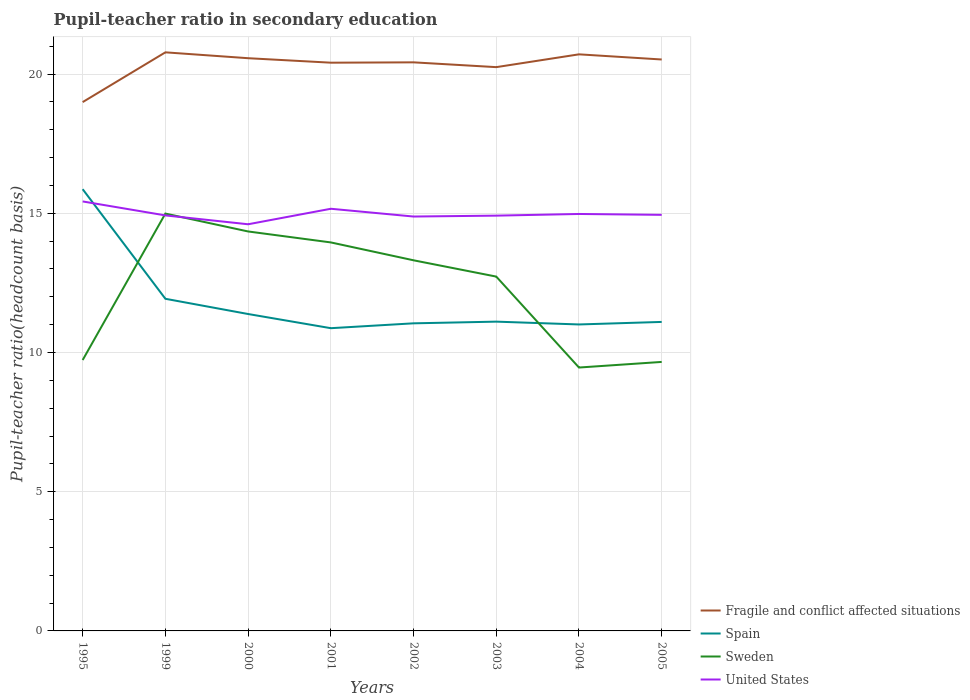Is the number of lines equal to the number of legend labels?
Offer a very short reply. Yes. Across all years, what is the maximum pupil-teacher ratio in secondary education in Spain?
Provide a succinct answer. 10.87. What is the total pupil-teacher ratio in secondary education in Fragile and conflict affected situations in the graph?
Your response must be concise. 0.17. What is the difference between the highest and the second highest pupil-teacher ratio in secondary education in Fragile and conflict affected situations?
Your response must be concise. 1.79. Is the pupil-teacher ratio in secondary education in United States strictly greater than the pupil-teacher ratio in secondary education in Sweden over the years?
Offer a terse response. No. Are the values on the major ticks of Y-axis written in scientific E-notation?
Make the answer very short. No. How many legend labels are there?
Your answer should be compact. 4. What is the title of the graph?
Keep it short and to the point. Pupil-teacher ratio in secondary education. Does "Colombia" appear as one of the legend labels in the graph?
Keep it short and to the point. No. What is the label or title of the X-axis?
Your answer should be compact. Years. What is the label or title of the Y-axis?
Your answer should be compact. Pupil-teacher ratio(headcount basis). What is the Pupil-teacher ratio(headcount basis) in Fragile and conflict affected situations in 1995?
Your answer should be very brief. 18.99. What is the Pupil-teacher ratio(headcount basis) in Spain in 1995?
Your answer should be compact. 15.87. What is the Pupil-teacher ratio(headcount basis) in Sweden in 1995?
Make the answer very short. 9.73. What is the Pupil-teacher ratio(headcount basis) of United States in 1995?
Make the answer very short. 15.43. What is the Pupil-teacher ratio(headcount basis) in Fragile and conflict affected situations in 1999?
Offer a very short reply. 20.78. What is the Pupil-teacher ratio(headcount basis) of Spain in 1999?
Your answer should be very brief. 11.93. What is the Pupil-teacher ratio(headcount basis) in Sweden in 1999?
Make the answer very short. 14.99. What is the Pupil-teacher ratio(headcount basis) of United States in 1999?
Offer a very short reply. 14.92. What is the Pupil-teacher ratio(headcount basis) of Fragile and conflict affected situations in 2000?
Make the answer very short. 20.57. What is the Pupil-teacher ratio(headcount basis) in Spain in 2000?
Your answer should be very brief. 11.38. What is the Pupil-teacher ratio(headcount basis) in Sweden in 2000?
Your answer should be very brief. 14.35. What is the Pupil-teacher ratio(headcount basis) of United States in 2000?
Make the answer very short. 14.61. What is the Pupil-teacher ratio(headcount basis) of Fragile and conflict affected situations in 2001?
Provide a short and direct response. 20.41. What is the Pupil-teacher ratio(headcount basis) in Spain in 2001?
Ensure brevity in your answer.  10.87. What is the Pupil-teacher ratio(headcount basis) of Sweden in 2001?
Offer a very short reply. 13.95. What is the Pupil-teacher ratio(headcount basis) in United States in 2001?
Your answer should be very brief. 15.16. What is the Pupil-teacher ratio(headcount basis) in Fragile and conflict affected situations in 2002?
Offer a terse response. 20.42. What is the Pupil-teacher ratio(headcount basis) in Spain in 2002?
Provide a succinct answer. 11.05. What is the Pupil-teacher ratio(headcount basis) of Sweden in 2002?
Your answer should be compact. 13.31. What is the Pupil-teacher ratio(headcount basis) in United States in 2002?
Keep it short and to the point. 14.88. What is the Pupil-teacher ratio(headcount basis) of Fragile and conflict affected situations in 2003?
Offer a terse response. 20.25. What is the Pupil-teacher ratio(headcount basis) in Spain in 2003?
Provide a short and direct response. 11.11. What is the Pupil-teacher ratio(headcount basis) in Sweden in 2003?
Make the answer very short. 12.73. What is the Pupil-teacher ratio(headcount basis) in United States in 2003?
Offer a very short reply. 14.92. What is the Pupil-teacher ratio(headcount basis) in Fragile and conflict affected situations in 2004?
Make the answer very short. 20.71. What is the Pupil-teacher ratio(headcount basis) in Spain in 2004?
Your answer should be compact. 11.01. What is the Pupil-teacher ratio(headcount basis) in Sweden in 2004?
Your answer should be very brief. 9.46. What is the Pupil-teacher ratio(headcount basis) in United States in 2004?
Ensure brevity in your answer.  14.98. What is the Pupil-teacher ratio(headcount basis) of Fragile and conflict affected situations in 2005?
Provide a succinct answer. 20.52. What is the Pupil-teacher ratio(headcount basis) in Spain in 2005?
Ensure brevity in your answer.  11.1. What is the Pupil-teacher ratio(headcount basis) in Sweden in 2005?
Make the answer very short. 9.66. What is the Pupil-teacher ratio(headcount basis) in United States in 2005?
Provide a succinct answer. 14.94. Across all years, what is the maximum Pupil-teacher ratio(headcount basis) in Fragile and conflict affected situations?
Provide a short and direct response. 20.78. Across all years, what is the maximum Pupil-teacher ratio(headcount basis) of Spain?
Offer a very short reply. 15.87. Across all years, what is the maximum Pupil-teacher ratio(headcount basis) of Sweden?
Provide a short and direct response. 14.99. Across all years, what is the maximum Pupil-teacher ratio(headcount basis) of United States?
Offer a very short reply. 15.43. Across all years, what is the minimum Pupil-teacher ratio(headcount basis) of Fragile and conflict affected situations?
Your response must be concise. 18.99. Across all years, what is the minimum Pupil-teacher ratio(headcount basis) of Spain?
Your answer should be very brief. 10.87. Across all years, what is the minimum Pupil-teacher ratio(headcount basis) in Sweden?
Your answer should be very brief. 9.46. Across all years, what is the minimum Pupil-teacher ratio(headcount basis) of United States?
Keep it short and to the point. 14.61. What is the total Pupil-teacher ratio(headcount basis) of Fragile and conflict affected situations in the graph?
Offer a very short reply. 162.66. What is the total Pupil-teacher ratio(headcount basis) in Spain in the graph?
Offer a very short reply. 94.31. What is the total Pupil-teacher ratio(headcount basis) in Sweden in the graph?
Provide a succinct answer. 98.18. What is the total Pupil-teacher ratio(headcount basis) of United States in the graph?
Provide a succinct answer. 119.84. What is the difference between the Pupil-teacher ratio(headcount basis) of Fragile and conflict affected situations in 1995 and that in 1999?
Your answer should be very brief. -1.79. What is the difference between the Pupil-teacher ratio(headcount basis) in Spain in 1995 and that in 1999?
Make the answer very short. 3.94. What is the difference between the Pupil-teacher ratio(headcount basis) of Sweden in 1995 and that in 1999?
Give a very brief answer. -5.26. What is the difference between the Pupil-teacher ratio(headcount basis) in United States in 1995 and that in 1999?
Make the answer very short. 0.5. What is the difference between the Pupil-teacher ratio(headcount basis) of Fragile and conflict affected situations in 1995 and that in 2000?
Ensure brevity in your answer.  -1.58. What is the difference between the Pupil-teacher ratio(headcount basis) of Spain in 1995 and that in 2000?
Provide a succinct answer. 4.48. What is the difference between the Pupil-teacher ratio(headcount basis) in Sweden in 1995 and that in 2000?
Your answer should be compact. -4.62. What is the difference between the Pupil-teacher ratio(headcount basis) in United States in 1995 and that in 2000?
Give a very brief answer. 0.82. What is the difference between the Pupil-teacher ratio(headcount basis) of Fragile and conflict affected situations in 1995 and that in 2001?
Your answer should be compact. -1.42. What is the difference between the Pupil-teacher ratio(headcount basis) of Spain in 1995 and that in 2001?
Your answer should be very brief. 4.99. What is the difference between the Pupil-teacher ratio(headcount basis) of Sweden in 1995 and that in 2001?
Provide a short and direct response. -4.22. What is the difference between the Pupil-teacher ratio(headcount basis) of United States in 1995 and that in 2001?
Your answer should be compact. 0.26. What is the difference between the Pupil-teacher ratio(headcount basis) in Fragile and conflict affected situations in 1995 and that in 2002?
Your answer should be compact. -1.43. What is the difference between the Pupil-teacher ratio(headcount basis) in Spain in 1995 and that in 2002?
Give a very brief answer. 4.82. What is the difference between the Pupil-teacher ratio(headcount basis) of Sweden in 1995 and that in 2002?
Your answer should be very brief. -3.58. What is the difference between the Pupil-teacher ratio(headcount basis) of United States in 1995 and that in 2002?
Offer a terse response. 0.54. What is the difference between the Pupil-teacher ratio(headcount basis) of Fragile and conflict affected situations in 1995 and that in 2003?
Offer a terse response. -1.26. What is the difference between the Pupil-teacher ratio(headcount basis) of Spain in 1995 and that in 2003?
Ensure brevity in your answer.  4.76. What is the difference between the Pupil-teacher ratio(headcount basis) of Sweden in 1995 and that in 2003?
Your answer should be compact. -3. What is the difference between the Pupil-teacher ratio(headcount basis) in United States in 1995 and that in 2003?
Ensure brevity in your answer.  0.51. What is the difference between the Pupil-teacher ratio(headcount basis) in Fragile and conflict affected situations in 1995 and that in 2004?
Provide a short and direct response. -1.72. What is the difference between the Pupil-teacher ratio(headcount basis) in Spain in 1995 and that in 2004?
Offer a very short reply. 4.86. What is the difference between the Pupil-teacher ratio(headcount basis) of Sweden in 1995 and that in 2004?
Offer a very short reply. 0.27. What is the difference between the Pupil-teacher ratio(headcount basis) in United States in 1995 and that in 2004?
Ensure brevity in your answer.  0.45. What is the difference between the Pupil-teacher ratio(headcount basis) of Fragile and conflict affected situations in 1995 and that in 2005?
Offer a terse response. -1.53. What is the difference between the Pupil-teacher ratio(headcount basis) in Spain in 1995 and that in 2005?
Offer a very short reply. 4.77. What is the difference between the Pupil-teacher ratio(headcount basis) of Sweden in 1995 and that in 2005?
Provide a short and direct response. 0.07. What is the difference between the Pupil-teacher ratio(headcount basis) in United States in 1995 and that in 2005?
Offer a very short reply. 0.48. What is the difference between the Pupil-teacher ratio(headcount basis) of Fragile and conflict affected situations in 1999 and that in 2000?
Ensure brevity in your answer.  0.21. What is the difference between the Pupil-teacher ratio(headcount basis) in Spain in 1999 and that in 2000?
Provide a short and direct response. 0.55. What is the difference between the Pupil-teacher ratio(headcount basis) of Sweden in 1999 and that in 2000?
Give a very brief answer. 0.64. What is the difference between the Pupil-teacher ratio(headcount basis) of United States in 1999 and that in 2000?
Your answer should be compact. 0.32. What is the difference between the Pupil-teacher ratio(headcount basis) of Fragile and conflict affected situations in 1999 and that in 2001?
Provide a short and direct response. 0.37. What is the difference between the Pupil-teacher ratio(headcount basis) of Spain in 1999 and that in 2001?
Ensure brevity in your answer.  1.06. What is the difference between the Pupil-teacher ratio(headcount basis) in Sweden in 1999 and that in 2001?
Keep it short and to the point. 1.04. What is the difference between the Pupil-teacher ratio(headcount basis) in United States in 1999 and that in 2001?
Ensure brevity in your answer.  -0.24. What is the difference between the Pupil-teacher ratio(headcount basis) of Fragile and conflict affected situations in 1999 and that in 2002?
Your answer should be very brief. 0.36. What is the difference between the Pupil-teacher ratio(headcount basis) of Spain in 1999 and that in 2002?
Offer a very short reply. 0.88. What is the difference between the Pupil-teacher ratio(headcount basis) of Sweden in 1999 and that in 2002?
Provide a short and direct response. 1.68. What is the difference between the Pupil-teacher ratio(headcount basis) of United States in 1999 and that in 2002?
Your response must be concise. 0.04. What is the difference between the Pupil-teacher ratio(headcount basis) in Fragile and conflict affected situations in 1999 and that in 2003?
Your answer should be compact. 0.53. What is the difference between the Pupil-teacher ratio(headcount basis) of Spain in 1999 and that in 2003?
Ensure brevity in your answer.  0.82. What is the difference between the Pupil-teacher ratio(headcount basis) in Sweden in 1999 and that in 2003?
Offer a very short reply. 2.26. What is the difference between the Pupil-teacher ratio(headcount basis) of United States in 1999 and that in 2003?
Your answer should be compact. 0.01. What is the difference between the Pupil-teacher ratio(headcount basis) of Fragile and conflict affected situations in 1999 and that in 2004?
Offer a very short reply. 0.07. What is the difference between the Pupil-teacher ratio(headcount basis) of Spain in 1999 and that in 2004?
Your response must be concise. 0.92. What is the difference between the Pupil-teacher ratio(headcount basis) in Sweden in 1999 and that in 2004?
Give a very brief answer. 5.53. What is the difference between the Pupil-teacher ratio(headcount basis) in United States in 1999 and that in 2004?
Make the answer very short. -0.05. What is the difference between the Pupil-teacher ratio(headcount basis) in Fragile and conflict affected situations in 1999 and that in 2005?
Ensure brevity in your answer.  0.26. What is the difference between the Pupil-teacher ratio(headcount basis) of Spain in 1999 and that in 2005?
Your response must be concise. 0.83. What is the difference between the Pupil-teacher ratio(headcount basis) in Sweden in 1999 and that in 2005?
Give a very brief answer. 5.33. What is the difference between the Pupil-teacher ratio(headcount basis) of United States in 1999 and that in 2005?
Make the answer very short. -0.02. What is the difference between the Pupil-teacher ratio(headcount basis) of Fragile and conflict affected situations in 2000 and that in 2001?
Your response must be concise. 0.16. What is the difference between the Pupil-teacher ratio(headcount basis) in Spain in 2000 and that in 2001?
Give a very brief answer. 0.51. What is the difference between the Pupil-teacher ratio(headcount basis) in Sweden in 2000 and that in 2001?
Offer a very short reply. 0.39. What is the difference between the Pupil-teacher ratio(headcount basis) in United States in 2000 and that in 2001?
Your answer should be compact. -0.56. What is the difference between the Pupil-teacher ratio(headcount basis) in Fragile and conflict affected situations in 2000 and that in 2002?
Provide a short and direct response. 0.15. What is the difference between the Pupil-teacher ratio(headcount basis) in Spain in 2000 and that in 2002?
Your answer should be very brief. 0.33. What is the difference between the Pupil-teacher ratio(headcount basis) of Sweden in 2000 and that in 2002?
Offer a very short reply. 1.04. What is the difference between the Pupil-teacher ratio(headcount basis) in United States in 2000 and that in 2002?
Ensure brevity in your answer.  -0.28. What is the difference between the Pupil-teacher ratio(headcount basis) of Fragile and conflict affected situations in 2000 and that in 2003?
Offer a terse response. 0.32. What is the difference between the Pupil-teacher ratio(headcount basis) of Spain in 2000 and that in 2003?
Ensure brevity in your answer.  0.27. What is the difference between the Pupil-teacher ratio(headcount basis) in Sweden in 2000 and that in 2003?
Give a very brief answer. 1.62. What is the difference between the Pupil-teacher ratio(headcount basis) of United States in 2000 and that in 2003?
Give a very brief answer. -0.31. What is the difference between the Pupil-teacher ratio(headcount basis) of Fragile and conflict affected situations in 2000 and that in 2004?
Offer a very short reply. -0.14. What is the difference between the Pupil-teacher ratio(headcount basis) in Sweden in 2000 and that in 2004?
Keep it short and to the point. 4.89. What is the difference between the Pupil-teacher ratio(headcount basis) in United States in 2000 and that in 2004?
Your answer should be very brief. -0.37. What is the difference between the Pupil-teacher ratio(headcount basis) of Fragile and conflict affected situations in 2000 and that in 2005?
Your response must be concise. 0.05. What is the difference between the Pupil-teacher ratio(headcount basis) of Spain in 2000 and that in 2005?
Provide a short and direct response. 0.28. What is the difference between the Pupil-teacher ratio(headcount basis) in Sweden in 2000 and that in 2005?
Your answer should be very brief. 4.69. What is the difference between the Pupil-teacher ratio(headcount basis) of United States in 2000 and that in 2005?
Keep it short and to the point. -0.34. What is the difference between the Pupil-teacher ratio(headcount basis) of Fragile and conflict affected situations in 2001 and that in 2002?
Provide a short and direct response. -0.01. What is the difference between the Pupil-teacher ratio(headcount basis) in Spain in 2001 and that in 2002?
Ensure brevity in your answer.  -0.17. What is the difference between the Pupil-teacher ratio(headcount basis) of Sweden in 2001 and that in 2002?
Your answer should be compact. 0.64. What is the difference between the Pupil-teacher ratio(headcount basis) in United States in 2001 and that in 2002?
Your answer should be compact. 0.28. What is the difference between the Pupil-teacher ratio(headcount basis) of Fragile and conflict affected situations in 2001 and that in 2003?
Offer a terse response. 0.16. What is the difference between the Pupil-teacher ratio(headcount basis) in Spain in 2001 and that in 2003?
Keep it short and to the point. -0.24. What is the difference between the Pupil-teacher ratio(headcount basis) of Sweden in 2001 and that in 2003?
Provide a succinct answer. 1.23. What is the difference between the Pupil-teacher ratio(headcount basis) in United States in 2001 and that in 2003?
Make the answer very short. 0.25. What is the difference between the Pupil-teacher ratio(headcount basis) in Fragile and conflict affected situations in 2001 and that in 2004?
Keep it short and to the point. -0.3. What is the difference between the Pupil-teacher ratio(headcount basis) in Spain in 2001 and that in 2004?
Your response must be concise. -0.13. What is the difference between the Pupil-teacher ratio(headcount basis) of Sweden in 2001 and that in 2004?
Offer a very short reply. 4.49. What is the difference between the Pupil-teacher ratio(headcount basis) in United States in 2001 and that in 2004?
Provide a succinct answer. 0.19. What is the difference between the Pupil-teacher ratio(headcount basis) in Fragile and conflict affected situations in 2001 and that in 2005?
Give a very brief answer. -0.11. What is the difference between the Pupil-teacher ratio(headcount basis) in Spain in 2001 and that in 2005?
Give a very brief answer. -0.22. What is the difference between the Pupil-teacher ratio(headcount basis) of Sweden in 2001 and that in 2005?
Provide a succinct answer. 4.29. What is the difference between the Pupil-teacher ratio(headcount basis) of United States in 2001 and that in 2005?
Offer a terse response. 0.22. What is the difference between the Pupil-teacher ratio(headcount basis) of Fragile and conflict affected situations in 2002 and that in 2003?
Make the answer very short. 0.17. What is the difference between the Pupil-teacher ratio(headcount basis) of Spain in 2002 and that in 2003?
Keep it short and to the point. -0.06. What is the difference between the Pupil-teacher ratio(headcount basis) in Sweden in 2002 and that in 2003?
Your answer should be compact. 0.59. What is the difference between the Pupil-teacher ratio(headcount basis) of United States in 2002 and that in 2003?
Provide a short and direct response. -0.03. What is the difference between the Pupil-teacher ratio(headcount basis) of Fragile and conflict affected situations in 2002 and that in 2004?
Your answer should be very brief. -0.29. What is the difference between the Pupil-teacher ratio(headcount basis) in Spain in 2002 and that in 2004?
Keep it short and to the point. 0.04. What is the difference between the Pupil-teacher ratio(headcount basis) in Sweden in 2002 and that in 2004?
Give a very brief answer. 3.85. What is the difference between the Pupil-teacher ratio(headcount basis) in United States in 2002 and that in 2004?
Make the answer very short. -0.09. What is the difference between the Pupil-teacher ratio(headcount basis) of Fragile and conflict affected situations in 2002 and that in 2005?
Your answer should be very brief. -0.1. What is the difference between the Pupil-teacher ratio(headcount basis) of Spain in 2002 and that in 2005?
Your answer should be very brief. -0.05. What is the difference between the Pupil-teacher ratio(headcount basis) in Sweden in 2002 and that in 2005?
Your answer should be compact. 3.65. What is the difference between the Pupil-teacher ratio(headcount basis) in United States in 2002 and that in 2005?
Provide a short and direct response. -0.06. What is the difference between the Pupil-teacher ratio(headcount basis) in Fragile and conflict affected situations in 2003 and that in 2004?
Give a very brief answer. -0.46. What is the difference between the Pupil-teacher ratio(headcount basis) in Spain in 2003 and that in 2004?
Offer a very short reply. 0.1. What is the difference between the Pupil-teacher ratio(headcount basis) of Sweden in 2003 and that in 2004?
Offer a very short reply. 3.27. What is the difference between the Pupil-teacher ratio(headcount basis) of United States in 2003 and that in 2004?
Make the answer very short. -0.06. What is the difference between the Pupil-teacher ratio(headcount basis) in Fragile and conflict affected situations in 2003 and that in 2005?
Offer a terse response. -0.27. What is the difference between the Pupil-teacher ratio(headcount basis) in Spain in 2003 and that in 2005?
Provide a short and direct response. 0.01. What is the difference between the Pupil-teacher ratio(headcount basis) of Sweden in 2003 and that in 2005?
Give a very brief answer. 3.06. What is the difference between the Pupil-teacher ratio(headcount basis) of United States in 2003 and that in 2005?
Make the answer very short. -0.03. What is the difference between the Pupil-teacher ratio(headcount basis) in Fragile and conflict affected situations in 2004 and that in 2005?
Provide a short and direct response. 0.19. What is the difference between the Pupil-teacher ratio(headcount basis) in Spain in 2004 and that in 2005?
Keep it short and to the point. -0.09. What is the difference between the Pupil-teacher ratio(headcount basis) of Sweden in 2004 and that in 2005?
Make the answer very short. -0.2. What is the difference between the Pupil-teacher ratio(headcount basis) in United States in 2004 and that in 2005?
Ensure brevity in your answer.  0.03. What is the difference between the Pupil-teacher ratio(headcount basis) of Fragile and conflict affected situations in 1995 and the Pupil-teacher ratio(headcount basis) of Spain in 1999?
Your answer should be compact. 7.06. What is the difference between the Pupil-teacher ratio(headcount basis) in Fragile and conflict affected situations in 1995 and the Pupil-teacher ratio(headcount basis) in Sweden in 1999?
Offer a very short reply. 4. What is the difference between the Pupil-teacher ratio(headcount basis) in Fragile and conflict affected situations in 1995 and the Pupil-teacher ratio(headcount basis) in United States in 1999?
Provide a short and direct response. 4.07. What is the difference between the Pupil-teacher ratio(headcount basis) of Spain in 1995 and the Pupil-teacher ratio(headcount basis) of Sweden in 1999?
Keep it short and to the point. 0.88. What is the difference between the Pupil-teacher ratio(headcount basis) in Spain in 1995 and the Pupil-teacher ratio(headcount basis) in United States in 1999?
Keep it short and to the point. 0.94. What is the difference between the Pupil-teacher ratio(headcount basis) in Sweden in 1995 and the Pupil-teacher ratio(headcount basis) in United States in 1999?
Your answer should be very brief. -5.19. What is the difference between the Pupil-teacher ratio(headcount basis) in Fragile and conflict affected situations in 1995 and the Pupil-teacher ratio(headcount basis) in Spain in 2000?
Your answer should be compact. 7.61. What is the difference between the Pupil-teacher ratio(headcount basis) of Fragile and conflict affected situations in 1995 and the Pupil-teacher ratio(headcount basis) of Sweden in 2000?
Offer a very short reply. 4.65. What is the difference between the Pupil-teacher ratio(headcount basis) of Fragile and conflict affected situations in 1995 and the Pupil-teacher ratio(headcount basis) of United States in 2000?
Your answer should be compact. 4.39. What is the difference between the Pupil-teacher ratio(headcount basis) of Spain in 1995 and the Pupil-teacher ratio(headcount basis) of Sweden in 2000?
Provide a succinct answer. 1.52. What is the difference between the Pupil-teacher ratio(headcount basis) in Spain in 1995 and the Pupil-teacher ratio(headcount basis) in United States in 2000?
Give a very brief answer. 1.26. What is the difference between the Pupil-teacher ratio(headcount basis) in Sweden in 1995 and the Pupil-teacher ratio(headcount basis) in United States in 2000?
Keep it short and to the point. -4.88. What is the difference between the Pupil-teacher ratio(headcount basis) of Fragile and conflict affected situations in 1995 and the Pupil-teacher ratio(headcount basis) of Spain in 2001?
Make the answer very short. 8.12. What is the difference between the Pupil-teacher ratio(headcount basis) of Fragile and conflict affected situations in 1995 and the Pupil-teacher ratio(headcount basis) of Sweden in 2001?
Offer a terse response. 5.04. What is the difference between the Pupil-teacher ratio(headcount basis) in Fragile and conflict affected situations in 1995 and the Pupil-teacher ratio(headcount basis) in United States in 2001?
Your response must be concise. 3.83. What is the difference between the Pupil-teacher ratio(headcount basis) of Spain in 1995 and the Pupil-teacher ratio(headcount basis) of Sweden in 2001?
Offer a very short reply. 1.91. What is the difference between the Pupil-teacher ratio(headcount basis) of Spain in 1995 and the Pupil-teacher ratio(headcount basis) of United States in 2001?
Your answer should be compact. 0.7. What is the difference between the Pupil-teacher ratio(headcount basis) in Sweden in 1995 and the Pupil-teacher ratio(headcount basis) in United States in 2001?
Your answer should be very brief. -5.43. What is the difference between the Pupil-teacher ratio(headcount basis) of Fragile and conflict affected situations in 1995 and the Pupil-teacher ratio(headcount basis) of Spain in 2002?
Offer a very short reply. 7.95. What is the difference between the Pupil-teacher ratio(headcount basis) of Fragile and conflict affected situations in 1995 and the Pupil-teacher ratio(headcount basis) of Sweden in 2002?
Keep it short and to the point. 5.68. What is the difference between the Pupil-teacher ratio(headcount basis) of Fragile and conflict affected situations in 1995 and the Pupil-teacher ratio(headcount basis) of United States in 2002?
Your answer should be compact. 4.11. What is the difference between the Pupil-teacher ratio(headcount basis) in Spain in 1995 and the Pupil-teacher ratio(headcount basis) in Sweden in 2002?
Ensure brevity in your answer.  2.55. What is the difference between the Pupil-teacher ratio(headcount basis) of Spain in 1995 and the Pupil-teacher ratio(headcount basis) of United States in 2002?
Make the answer very short. 0.98. What is the difference between the Pupil-teacher ratio(headcount basis) of Sweden in 1995 and the Pupil-teacher ratio(headcount basis) of United States in 2002?
Your response must be concise. -5.15. What is the difference between the Pupil-teacher ratio(headcount basis) in Fragile and conflict affected situations in 1995 and the Pupil-teacher ratio(headcount basis) in Spain in 2003?
Provide a short and direct response. 7.89. What is the difference between the Pupil-teacher ratio(headcount basis) of Fragile and conflict affected situations in 1995 and the Pupil-teacher ratio(headcount basis) of Sweden in 2003?
Your response must be concise. 6.27. What is the difference between the Pupil-teacher ratio(headcount basis) of Fragile and conflict affected situations in 1995 and the Pupil-teacher ratio(headcount basis) of United States in 2003?
Give a very brief answer. 4.08. What is the difference between the Pupil-teacher ratio(headcount basis) in Spain in 1995 and the Pupil-teacher ratio(headcount basis) in Sweden in 2003?
Offer a very short reply. 3.14. What is the difference between the Pupil-teacher ratio(headcount basis) of Spain in 1995 and the Pupil-teacher ratio(headcount basis) of United States in 2003?
Provide a succinct answer. 0.95. What is the difference between the Pupil-teacher ratio(headcount basis) of Sweden in 1995 and the Pupil-teacher ratio(headcount basis) of United States in 2003?
Give a very brief answer. -5.19. What is the difference between the Pupil-teacher ratio(headcount basis) of Fragile and conflict affected situations in 1995 and the Pupil-teacher ratio(headcount basis) of Spain in 2004?
Your answer should be very brief. 7.99. What is the difference between the Pupil-teacher ratio(headcount basis) in Fragile and conflict affected situations in 1995 and the Pupil-teacher ratio(headcount basis) in Sweden in 2004?
Keep it short and to the point. 9.53. What is the difference between the Pupil-teacher ratio(headcount basis) of Fragile and conflict affected situations in 1995 and the Pupil-teacher ratio(headcount basis) of United States in 2004?
Your answer should be compact. 4.02. What is the difference between the Pupil-teacher ratio(headcount basis) in Spain in 1995 and the Pupil-teacher ratio(headcount basis) in Sweden in 2004?
Provide a succinct answer. 6.41. What is the difference between the Pupil-teacher ratio(headcount basis) of Spain in 1995 and the Pupil-teacher ratio(headcount basis) of United States in 2004?
Your response must be concise. 0.89. What is the difference between the Pupil-teacher ratio(headcount basis) of Sweden in 1995 and the Pupil-teacher ratio(headcount basis) of United States in 2004?
Your answer should be compact. -5.25. What is the difference between the Pupil-teacher ratio(headcount basis) of Fragile and conflict affected situations in 1995 and the Pupil-teacher ratio(headcount basis) of Spain in 2005?
Ensure brevity in your answer.  7.9. What is the difference between the Pupil-teacher ratio(headcount basis) in Fragile and conflict affected situations in 1995 and the Pupil-teacher ratio(headcount basis) in Sweden in 2005?
Keep it short and to the point. 9.33. What is the difference between the Pupil-teacher ratio(headcount basis) of Fragile and conflict affected situations in 1995 and the Pupil-teacher ratio(headcount basis) of United States in 2005?
Provide a succinct answer. 4.05. What is the difference between the Pupil-teacher ratio(headcount basis) of Spain in 1995 and the Pupil-teacher ratio(headcount basis) of Sweden in 2005?
Give a very brief answer. 6.2. What is the difference between the Pupil-teacher ratio(headcount basis) in Spain in 1995 and the Pupil-teacher ratio(headcount basis) in United States in 2005?
Ensure brevity in your answer.  0.92. What is the difference between the Pupil-teacher ratio(headcount basis) in Sweden in 1995 and the Pupil-teacher ratio(headcount basis) in United States in 2005?
Offer a terse response. -5.21. What is the difference between the Pupil-teacher ratio(headcount basis) in Fragile and conflict affected situations in 1999 and the Pupil-teacher ratio(headcount basis) in Spain in 2000?
Ensure brevity in your answer.  9.4. What is the difference between the Pupil-teacher ratio(headcount basis) in Fragile and conflict affected situations in 1999 and the Pupil-teacher ratio(headcount basis) in Sweden in 2000?
Your answer should be very brief. 6.43. What is the difference between the Pupil-teacher ratio(headcount basis) of Fragile and conflict affected situations in 1999 and the Pupil-teacher ratio(headcount basis) of United States in 2000?
Your answer should be compact. 6.18. What is the difference between the Pupil-teacher ratio(headcount basis) of Spain in 1999 and the Pupil-teacher ratio(headcount basis) of Sweden in 2000?
Offer a very short reply. -2.42. What is the difference between the Pupil-teacher ratio(headcount basis) in Spain in 1999 and the Pupil-teacher ratio(headcount basis) in United States in 2000?
Offer a very short reply. -2.68. What is the difference between the Pupil-teacher ratio(headcount basis) in Sweden in 1999 and the Pupil-teacher ratio(headcount basis) in United States in 2000?
Give a very brief answer. 0.38. What is the difference between the Pupil-teacher ratio(headcount basis) in Fragile and conflict affected situations in 1999 and the Pupil-teacher ratio(headcount basis) in Spain in 2001?
Ensure brevity in your answer.  9.91. What is the difference between the Pupil-teacher ratio(headcount basis) of Fragile and conflict affected situations in 1999 and the Pupil-teacher ratio(headcount basis) of Sweden in 2001?
Your answer should be very brief. 6.83. What is the difference between the Pupil-teacher ratio(headcount basis) in Fragile and conflict affected situations in 1999 and the Pupil-teacher ratio(headcount basis) in United States in 2001?
Offer a very short reply. 5.62. What is the difference between the Pupil-teacher ratio(headcount basis) in Spain in 1999 and the Pupil-teacher ratio(headcount basis) in Sweden in 2001?
Your answer should be very brief. -2.02. What is the difference between the Pupil-teacher ratio(headcount basis) of Spain in 1999 and the Pupil-teacher ratio(headcount basis) of United States in 2001?
Your answer should be compact. -3.23. What is the difference between the Pupil-teacher ratio(headcount basis) in Sweden in 1999 and the Pupil-teacher ratio(headcount basis) in United States in 2001?
Make the answer very short. -0.17. What is the difference between the Pupil-teacher ratio(headcount basis) in Fragile and conflict affected situations in 1999 and the Pupil-teacher ratio(headcount basis) in Spain in 2002?
Make the answer very short. 9.73. What is the difference between the Pupil-teacher ratio(headcount basis) of Fragile and conflict affected situations in 1999 and the Pupil-teacher ratio(headcount basis) of Sweden in 2002?
Provide a succinct answer. 7.47. What is the difference between the Pupil-teacher ratio(headcount basis) in Fragile and conflict affected situations in 1999 and the Pupil-teacher ratio(headcount basis) in United States in 2002?
Make the answer very short. 5.9. What is the difference between the Pupil-teacher ratio(headcount basis) in Spain in 1999 and the Pupil-teacher ratio(headcount basis) in Sweden in 2002?
Give a very brief answer. -1.38. What is the difference between the Pupil-teacher ratio(headcount basis) of Spain in 1999 and the Pupil-teacher ratio(headcount basis) of United States in 2002?
Ensure brevity in your answer.  -2.95. What is the difference between the Pupil-teacher ratio(headcount basis) of Sweden in 1999 and the Pupil-teacher ratio(headcount basis) of United States in 2002?
Your answer should be compact. 0.11. What is the difference between the Pupil-teacher ratio(headcount basis) in Fragile and conflict affected situations in 1999 and the Pupil-teacher ratio(headcount basis) in Spain in 2003?
Make the answer very short. 9.67. What is the difference between the Pupil-teacher ratio(headcount basis) in Fragile and conflict affected situations in 1999 and the Pupil-teacher ratio(headcount basis) in Sweden in 2003?
Your answer should be very brief. 8.05. What is the difference between the Pupil-teacher ratio(headcount basis) of Fragile and conflict affected situations in 1999 and the Pupil-teacher ratio(headcount basis) of United States in 2003?
Your answer should be compact. 5.87. What is the difference between the Pupil-teacher ratio(headcount basis) in Spain in 1999 and the Pupil-teacher ratio(headcount basis) in Sweden in 2003?
Ensure brevity in your answer.  -0.8. What is the difference between the Pupil-teacher ratio(headcount basis) in Spain in 1999 and the Pupil-teacher ratio(headcount basis) in United States in 2003?
Your response must be concise. -2.99. What is the difference between the Pupil-teacher ratio(headcount basis) of Sweden in 1999 and the Pupil-teacher ratio(headcount basis) of United States in 2003?
Ensure brevity in your answer.  0.07. What is the difference between the Pupil-teacher ratio(headcount basis) of Fragile and conflict affected situations in 1999 and the Pupil-teacher ratio(headcount basis) of Spain in 2004?
Make the answer very short. 9.77. What is the difference between the Pupil-teacher ratio(headcount basis) in Fragile and conflict affected situations in 1999 and the Pupil-teacher ratio(headcount basis) in Sweden in 2004?
Keep it short and to the point. 11.32. What is the difference between the Pupil-teacher ratio(headcount basis) in Fragile and conflict affected situations in 1999 and the Pupil-teacher ratio(headcount basis) in United States in 2004?
Ensure brevity in your answer.  5.81. What is the difference between the Pupil-teacher ratio(headcount basis) of Spain in 1999 and the Pupil-teacher ratio(headcount basis) of Sweden in 2004?
Ensure brevity in your answer.  2.47. What is the difference between the Pupil-teacher ratio(headcount basis) in Spain in 1999 and the Pupil-teacher ratio(headcount basis) in United States in 2004?
Offer a very short reply. -3.05. What is the difference between the Pupil-teacher ratio(headcount basis) in Sweden in 1999 and the Pupil-teacher ratio(headcount basis) in United States in 2004?
Your answer should be compact. 0.01. What is the difference between the Pupil-teacher ratio(headcount basis) of Fragile and conflict affected situations in 1999 and the Pupil-teacher ratio(headcount basis) of Spain in 2005?
Provide a succinct answer. 9.68. What is the difference between the Pupil-teacher ratio(headcount basis) in Fragile and conflict affected situations in 1999 and the Pupil-teacher ratio(headcount basis) in Sweden in 2005?
Provide a short and direct response. 11.12. What is the difference between the Pupil-teacher ratio(headcount basis) in Fragile and conflict affected situations in 1999 and the Pupil-teacher ratio(headcount basis) in United States in 2005?
Offer a very short reply. 5.84. What is the difference between the Pupil-teacher ratio(headcount basis) in Spain in 1999 and the Pupil-teacher ratio(headcount basis) in Sweden in 2005?
Keep it short and to the point. 2.27. What is the difference between the Pupil-teacher ratio(headcount basis) of Spain in 1999 and the Pupil-teacher ratio(headcount basis) of United States in 2005?
Make the answer very short. -3.01. What is the difference between the Pupil-teacher ratio(headcount basis) of Sweden in 1999 and the Pupil-teacher ratio(headcount basis) of United States in 2005?
Offer a terse response. 0.05. What is the difference between the Pupil-teacher ratio(headcount basis) of Fragile and conflict affected situations in 2000 and the Pupil-teacher ratio(headcount basis) of Spain in 2001?
Offer a terse response. 9.7. What is the difference between the Pupil-teacher ratio(headcount basis) of Fragile and conflict affected situations in 2000 and the Pupil-teacher ratio(headcount basis) of Sweden in 2001?
Ensure brevity in your answer.  6.62. What is the difference between the Pupil-teacher ratio(headcount basis) in Fragile and conflict affected situations in 2000 and the Pupil-teacher ratio(headcount basis) in United States in 2001?
Offer a terse response. 5.41. What is the difference between the Pupil-teacher ratio(headcount basis) of Spain in 2000 and the Pupil-teacher ratio(headcount basis) of Sweden in 2001?
Provide a short and direct response. -2.57. What is the difference between the Pupil-teacher ratio(headcount basis) in Spain in 2000 and the Pupil-teacher ratio(headcount basis) in United States in 2001?
Provide a succinct answer. -3.78. What is the difference between the Pupil-teacher ratio(headcount basis) of Sweden in 2000 and the Pupil-teacher ratio(headcount basis) of United States in 2001?
Offer a terse response. -0.82. What is the difference between the Pupil-teacher ratio(headcount basis) of Fragile and conflict affected situations in 2000 and the Pupil-teacher ratio(headcount basis) of Spain in 2002?
Provide a short and direct response. 9.52. What is the difference between the Pupil-teacher ratio(headcount basis) in Fragile and conflict affected situations in 2000 and the Pupil-teacher ratio(headcount basis) in Sweden in 2002?
Offer a terse response. 7.26. What is the difference between the Pupil-teacher ratio(headcount basis) in Fragile and conflict affected situations in 2000 and the Pupil-teacher ratio(headcount basis) in United States in 2002?
Provide a succinct answer. 5.69. What is the difference between the Pupil-teacher ratio(headcount basis) of Spain in 2000 and the Pupil-teacher ratio(headcount basis) of Sweden in 2002?
Give a very brief answer. -1.93. What is the difference between the Pupil-teacher ratio(headcount basis) of Spain in 2000 and the Pupil-teacher ratio(headcount basis) of United States in 2002?
Make the answer very short. -3.5. What is the difference between the Pupil-teacher ratio(headcount basis) of Sweden in 2000 and the Pupil-teacher ratio(headcount basis) of United States in 2002?
Provide a short and direct response. -0.54. What is the difference between the Pupil-teacher ratio(headcount basis) of Fragile and conflict affected situations in 2000 and the Pupil-teacher ratio(headcount basis) of Spain in 2003?
Provide a short and direct response. 9.46. What is the difference between the Pupil-teacher ratio(headcount basis) of Fragile and conflict affected situations in 2000 and the Pupil-teacher ratio(headcount basis) of Sweden in 2003?
Give a very brief answer. 7.84. What is the difference between the Pupil-teacher ratio(headcount basis) of Fragile and conflict affected situations in 2000 and the Pupil-teacher ratio(headcount basis) of United States in 2003?
Your answer should be very brief. 5.65. What is the difference between the Pupil-teacher ratio(headcount basis) in Spain in 2000 and the Pupil-teacher ratio(headcount basis) in Sweden in 2003?
Keep it short and to the point. -1.34. What is the difference between the Pupil-teacher ratio(headcount basis) of Spain in 2000 and the Pupil-teacher ratio(headcount basis) of United States in 2003?
Ensure brevity in your answer.  -3.53. What is the difference between the Pupil-teacher ratio(headcount basis) in Sweden in 2000 and the Pupil-teacher ratio(headcount basis) in United States in 2003?
Make the answer very short. -0.57. What is the difference between the Pupil-teacher ratio(headcount basis) of Fragile and conflict affected situations in 2000 and the Pupil-teacher ratio(headcount basis) of Spain in 2004?
Provide a succinct answer. 9.56. What is the difference between the Pupil-teacher ratio(headcount basis) in Fragile and conflict affected situations in 2000 and the Pupil-teacher ratio(headcount basis) in Sweden in 2004?
Ensure brevity in your answer.  11.11. What is the difference between the Pupil-teacher ratio(headcount basis) of Fragile and conflict affected situations in 2000 and the Pupil-teacher ratio(headcount basis) of United States in 2004?
Offer a very short reply. 5.59. What is the difference between the Pupil-teacher ratio(headcount basis) of Spain in 2000 and the Pupil-teacher ratio(headcount basis) of Sweden in 2004?
Make the answer very short. 1.92. What is the difference between the Pupil-teacher ratio(headcount basis) of Spain in 2000 and the Pupil-teacher ratio(headcount basis) of United States in 2004?
Make the answer very short. -3.59. What is the difference between the Pupil-teacher ratio(headcount basis) in Sweden in 2000 and the Pupil-teacher ratio(headcount basis) in United States in 2004?
Your answer should be compact. -0.63. What is the difference between the Pupil-teacher ratio(headcount basis) of Fragile and conflict affected situations in 2000 and the Pupil-teacher ratio(headcount basis) of Spain in 2005?
Provide a short and direct response. 9.47. What is the difference between the Pupil-teacher ratio(headcount basis) in Fragile and conflict affected situations in 2000 and the Pupil-teacher ratio(headcount basis) in Sweden in 2005?
Provide a short and direct response. 10.91. What is the difference between the Pupil-teacher ratio(headcount basis) of Fragile and conflict affected situations in 2000 and the Pupil-teacher ratio(headcount basis) of United States in 2005?
Give a very brief answer. 5.63. What is the difference between the Pupil-teacher ratio(headcount basis) in Spain in 2000 and the Pupil-teacher ratio(headcount basis) in Sweden in 2005?
Make the answer very short. 1.72. What is the difference between the Pupil-teacher ratio(headcount basis) of Spain in 2000 and the Pupil-teacher ratio(headcount basis) of United States in 2005?
Provide a short and direct response. -3.56. What is the difference between the Pupil-teacher ratio(headcount basis) of Sweden in 2000 and the Pupil-teacher ratio(headcount basis) of United States in 2005?
Provide a succinct answer. -0.6. What is the difference between the Pupil-teacher ratio(headcount basis) in Fragile and conflict affected situations in 2001 and the Pupil-teacher ratio(headcount basis) in Spain in 2002?
Provide a succinct answer. 9.36. What is the difference between the Pupil-teacher ratio(headcount basis) in Fragile and conflict affected situations in 2001 and the Pupil-teacher ratio(headcount basis) in Sweden in 2002?
Provide a succinct answer. 7.1. What is the difference between the Pupil-teacher ratio(headcount basis) in Fragile and conflict affected situations in 2001 and the Pupil-teacher ratio(headcount basis) in United States in 2002?
Keep it short and to the point. 5.53. What is the difference between the Pupil-teacher ratio(headcount basis) in Spain in 2001 and the Pupil-teacher ratio(headcount basis) in Sweden in 2002?
Keep it short and to the point. -2.44. What is the difference between the Pupil-teacher ratio(headcount basis) of Spain in 2001 and the Pupil-teacher ratio(headcount basis) of United States in 2002?
Ensure brevity in your answer.  -4.01. What is the difference between the Pupil-teacher ratio(headcount basis) in Sweden in 2001 and the Pupil-teacher ratio(headcount basis) in United States in 2002?
Provide a short and direct response. -0.93. What is the difference between the Pupil-teacher ratio(headcount basis) of Fragile and conflict affected situations in 2001 and the Pupil-teacher ratio(headcount basis) of Spain in 2003?
Provide a succinct answer. 9.3. What is the difference between the Pupil-teacher ratio(headcount basis) in Fragile and conflict affected situations in 2001 and the Pupil-teacher ratio(headcount basis) in Sweden in 2003?
Offer a very short reply. 7.68. What is the difference between the Pupil-teacher ratio(headcount basis) in Fragile and conflict affected situations in 2001 and the Pupil-teacher ratio(headcount basis) in United States in 2003?
Keep it short and to the point. 5.49. What is the difference between the Pupil-teacher ratio(headcount basis) in Spain in 2001 and the Pupil-teacher ratio(headcount basis) in Sweden in 2003?
Provide a short and direct response. -1.85. What is the difference between the Pupil-teacher ratio(headcount basis) in Spain in 2001 and the Pupil-teacher ratio(headcount basis) in United States in 2003?
Give a very brief answer. -4.04. What is the difference between the Pupil-teacher ratio(headcount basis) in Sweden in 2001 and the Pupil-teacher ratio(headcount basis) in United States in 2003?
Your answer should be very brief. -0.96. What is the difference between the Pupil-teacher ratio(headcount basis) of Fragile and conflict affected situations in 2001 and the Pupil-teacher ratio(headcount basis) of Spain in 2004?
Your response must be concise. 9.4. What is the difference between the Pupil-teacher ratio(headcount basis) in Fragile and conflict affected situations in 2001 and the Pupil-teacher ratio(headcount basis) in Sweden in 2004?
Your answer should be compact. 10.95. What is the difference between the Pupil-teacher ratio(headcount basis) of Fragile and conflict affected situations in 2001 and the Pupil-teacher ratio(headcount basis) of United States in 2004?
Your answer should be compact. 5.43. What is the difference between the Pupil-teacher ratio(headcount basis) of Spain in 2001 and the Pupil-teacher ratio(headcount basis) of Sweden in 2004?
Your answer should be very brief. 1.41. What is the difference between the Pupil-teacher ratio(headcount basis) in Spain in 2001 and the Pupil-teacher ratio(headcount basis) in United States in 2004?
Give a very brief answer. -4.1. What is the difference between the Pupil-teacher ratio(headcount basis) in Sweden in 2001 and the Pupil-teacher ratio(headcount basis) in United States in 2004?
Provide a short and direct response. -1.02. What is the difference between the Pupil-teacher ratio(headcount basis) in Fragile and conflict affected situations in 2001 and the Pupil-teacher ratio(headcount basis) in Spain in 2005?
Offer a terse response. 9.31. What is the difference between the Pupil-teacher ratio(headcount basis) in Fragile and conflict affected situations in 2001 and the Pupil-teacher ratio(headcount basis) in Sweden in 2005?
Your answer should be compact. 10.75. What is the difference between the Pupil-teacher ratio(headcount basis) in Fragile and conflict affected situations in 2001 and the Pupil-teacher ratio(headcount basis) in United States in 2005?
Provide a succinct answer. 5.47. What is the difference between the Pupil-teacher ratio(headcount basis) of Spain in 2001 and the Pupil-teacher ratio(headcount basis) of Sweden in 2005?
Provide a short and direct response. 1.21. What is the difference between the Pupil-teacher ratio(headcount basis) of Spain in 2001 and the Pupil-teacher ratio(headcount basis) of United States in 2005?
Keep it short and to the point. -4.07. What is the difference between the Pupil-teacher ratio(headcount basis) in Sweden in 2001 and the Pupil-teacher ratio(headcount basis) in United States in 2005?
Keep it short and to the point. -0.99. What is the difference between the Pupil-teacher ratio(headcount basis) of Fragile and conflict affected situations in 2002 and the Pupil-teacher ratio(headcount basis) of Spain in 2003?
Offer a very short reply. 9.31. What is the difference between the Pupil-teacher ratio(headcount basis) in Fragile and conflict affected situations in 2002 and the Pupil-teacher ratio(headcount basis) in Sweden in 2003?
Make the answer very short. 7.7. What is the difference between the Pupil-teacher ratio(headcount basis) in Fragile and conflict affected situations in 2002 and the Pupil-teacher ratio(headcount basis) in United States in 2003?
Offer a terse response. 5.51. What is the difference between the Pupil-teacher ratio(headcount basis) of Spain in 2002 and the Pupil-teacher ratio(headcount basis) of Sweden in 2003?
Your answer should be very brief. -1.68. What is the difference between the Pupil-teacher ratio(headcount basis) of Spain in 2002 and the Pupil-teacher ratio(headcount basis) of United States in 2003?
Your answer should be very brief. -3.87. What is the difference between the Pupil-teacher ratio(headcount basis) in Sweden in 2002 and the Pupil-teacher ratio(headcount basis) in United States in 2003?
Make the answer very short. -1.6. What is the difference between the Pupil-teacher ratio(headcount basis) of Fragile and conflict affected situations in 2002 and the Pupil-teacher ratio(headcount basis) of Spain in 2004?
Your answer should be very brief. 9.41. What is the difference between the Pupil-teacher ratio(headcount basis) of Fragile and conflict affected situations in 2002 and the Pupil-teacher ratio(headcount basis) of Sweden in 2004?
Keep it short and to the point. 10.96. What is the difference between the Pupil-teacher ratio(headcount basis) in Fragile and conflict affected situations in 2002 and the Pupil-teacher ratio(headcount basis) in United States in 2004?
Keep it short and to the point. 5.45. What is the difference between the Pupil-teacher ratio(headcount basis) in Spain in 2002 and the Pupil-teacher ratio(headcount basis) in Sweden in 2004?
Provide a short and direct response. 1.59. What is the difference between the Pupil-teacher ratio(headcount basis) of Spain in 2002 and the Pupil-teacher ratio(headcount basis) of United States in 2004?
Ensure brevity in your answer.  -3.93. What is the difference between the Pupil-teacher ratio(headcount basis) of Sweden in 2002 and the Pupil-teacher ratio(headcount basis) of United States in 2004?
Offer a very short reply. -1.66. What is the difference between the Pupil-teacher ratio(headcount basis) of Fragile and conflict affected situations in 2002 and the Pupil-teacher ratio(headcount basis) of Spain in 2005?
Make the answer very short. 9.32. What is the difference between the Pupil-teacher ratio(headcount basis) in Fragile and conflict affected situations in 2002 and the Pupil-teacher ratio(headcount basis) in Sweden in 2005?
Offer a very short reply. 10.76. What is the difference between the Pupil-teacher ratio(headcount basis) in Fragile and conflict affected situations in 2002 and the Pupil-teacher ratio(headcount basis) in United States in 2005?
Offer a terse response. 5.48. What is the difference between the Pupil-teacher ratio(headcount basis) of Spain in 2002 and the Pupil-teacher ratio(headcount basis) of Sweden in 2005?
Your response must be concise. 1.39. What is the difference between the Pupil-teacher ratio(headcount basis) of Spain in 2002 and the Pupil-teacher ratio(headcount basis) of United States in 2005?
Your answer should be very brief. -3.9. What is the difference between the Pupil-teacher ratio(headcount basis) of Sweden in 2002 and the Pupil-teacher ratio(headcount basis) of United States in 2005?
Offer a very short reply. -1.63. What is the difference between the Pupil-teacher ratio(headcount basis) in Fragile and conflict affected situations in 2003 and the Pupil-teacher ratio(headcount basis) in Spain in 2004?
Your response must be concise. 9.24. What is the difference between the Pupil-teacher ratio(headcount basis) of Fragile and conflict affected situations in 2003 and the Pupil-teacher ratio(headcount basis) of Sweden in 2004?
Keep it short and to the point. 10.79. What is the difference between the Pupil-teacher ratio(headcount basis) of Fragile and conflict affected situations in 2003 and the Pupil-teacher ratio(headcount basis) of United States in 2004?
Your response must be concise. 5.27. What is the difference between the Pupil-teacher ratio(headcount basis) of Spain in 2003 and the Pupil-teacher ratio(headcount basis) of Sweden in 2004?
Make the answer very short. 1.65. What is the difference between the Pupil-teacher ratio(headcount basis) in Spain in 2003 and the Pupil-teacher ratio(headcount basis) in United States in 2004?
Your response must be concise. -3.87. What is the difference between the Pupil-teacher ratio(headcount basis) in Sweden in 2003 and the Pupil-teacher ratio(headcount basis) in United States in 2004?
Offer a terse response. -2.25. What is the difference between the Pupil-teacher ratio(headcount basis) in Fragile and conflict affected situations in 2003 and the Pupil-teacher ratio(headcount basis) in Spain in 2005?
Give a very brief answer. 9.15. What is the difference between the Pupil-teacher ratio(headcount basis) in Fragile and conflict affected situations in 2003 and the Pupil-teacher ratio(headcount basis) in Sweden in 2005?
Give a very brief answer. 10.59. What is the difference between the Pupil-teacher ratio(headcount basis) of Fragile and conflict affected situations in 2003 and the Pupil-teacher ratio(headcount basis) of United States in 2005?
Provide a short and direct response. 5.31. What is the difference between the Pupil-teacher ratio(headcount basis) in Spain in 2003 and the Pupil-teacher ratio(headcount basis) in Sweden in 2005?
Your answer should be compact. 1.45. What is the difference between the Pupil-teacher ratio(headcount basis) of Spain in 2003 and the Pupil-teacher ratio(headcount basis) of United States in 2005?
Ensure brevity in your answer.  -3.84. What is the difference between the Pupil-teacher ratio(headcount basis) of Sweden in 2003 and the Pupil-teacher ratio(headcount basis) of United States in 2005?
Your answer should be compact. -2.22. What is the difference between the Pupil-teacher ratio(headcount basis) in Fragile and conflict affected situations in 2004 and the Pupil-teacher ratio(headcount basis) in Spain in 2005?
Offer a terse response. 9.61. What is the difference between the Pupil-teacher ratio(headcount basis) in Fragile and conflict affected situations in 2004 and the Pupil-teacher ratio(headcount basis) in Sweden in 2005?
Provide a succinct answer. 11.05. What is the difference between the Pupil-teacher ratio(headcount basis) of Fragile and conflict affected situations in 2004 and the Pupil-teacher ratio(headcount basis) of United States in 2005?
Give a very brief answer. 5.76. What is the difference between the Pupil-teacher ratio(headcount basis) of Spain in 2004 and the Pupil-teacher ratio(headcount basis) of Sweden in 2005?
Keep it short and to the point. 1.35. What is the difference between the Pupil-teacher ratio(headcount basis) of Spain in 2004 and the Pupil-teacher ratio(headcount basis) of United States in 2005?
Offer a very short reply. -3.94. What is the difference between the Pupil-teacher ratio(headcount basis) of Sweden in 2004 and the Pupil-teacher ratio(headcount basis) of United States in 2005?
Provide a short and direct response. -5.48. What is the average Pupil-teacher ratio(headcount basis) in Fragile and conflict affected situations per year?
Give a very brief answer. 20.33. What is the average Pupil-teacher ratio(headcount basis) in Spain per year?
Offer a very short reply. 11.79. What is the average Pupil-teacher ratio(headcount basis) in Sweden per year?
Keep it short and to the point. 12.27. What is the average Pupil-teacher ratio(headcount basis) in United States per year?
Your answer should be compact. 14.98. In the year 1995, what is the difference between the Pupil-teacher ratio(headcount basis) in Fragile and conflict affected situations and Pupil-teacher ratio(headcount basis) in Spain?
Your response must be concise. 3.13. In the year 1995, what is the difference between the Pupil-teacher ratio(headcount basis) of Fragile and conflict affected situations and Pupil-teacher ratio(headcount basis) of Sweden?
Provide a succinct answer. 9.26. In the year 1995, what is the difference between the Pupil-teacher ratio(headcount basis) in Fragile and conflict affected situations and Pupil-teacher ratio(headcount basis) in United States?
Keep it short and to the point. 3.57. In the year 1995, what is the difference between the Pupil-teacher ratio(headcount basis) of Spain and Pupil-teacher ratio(headcount basis) of Sweden?
Your answer should be very brief. 6.14. In the year 1995, what is the difference between the Pupil-teacher ratio(headcount basis) in Spain and Pupil-teacher ratio(headcount basis) in United States?
Your answer should be compact. 0.44. In the year 1995, what is the difference between the Pupil-teacher ratio(headcount basis) in Sweden and Pupil-teacher ratio(headcount basis) in United States?
Make the answer very short. -5.7. In the year 1999, what is the difference between the Pupil-teacher ratio(headcount basis) in Fragile and conflict affected situations and Pupil-teacher ratio(headcount basis) in Spain?
Offer a terse response. 8.85. In the year 1999, what is the difference between the Pupil-teacher ratio(headcount basis) of Fragile and conflict affected situations and Pupil-teacher ratio(headcount basis) of Sweden?
Give a very brief answer. 5.79. In the year 1999, what is the difference between the Pupil-teacher ratio(headcount basis) of Fragile and conflict affected situations and Pupil-teacher ratio(headcount basis) of United States?
Your answer should be compact. 5.86. In the year 1999, what is the difference between the Pupil-teacher ratio(headcount basis) in Spain and Pupil-teacher ratio(headcount basis) in Sweden?
Ensure brevity in your answer.  -3.06. In the year 1999, what is the difference between the Pupil-teacher ratio(headcount basis) of Spain and Pupil-teacher ratio(headcount basis) of United States?
Give a very brief answer. -2.99. In the year 1999, what is the difference between the Pupil-teacher ratio(headcount basis) of Sweden and Pupil-teacher ratio(headcount basis) of United States?
Provide a short and direct response. 0.07. In the year 2000, what is the difference between the Pupil-teacher ratio(headcount basis) of Fragile and conflict affected situations and Pupil-teacher ratio(headcount basis) of Spain?
Ensure brevity in your answer.  9.19. In the year 2000, what is the difference between the Pupil-teacher ratio(headcount basis) of Fragile and conflict affected situations and Pupil-teacher ratio(headcount basis) of Sweden?
Your answer should be compact. 6.22. In the year 2000, what is the difference between the Pupil-teacher ratio(headcount basis) in Fragile and conflict affected situations and Pupil-teacher ratio(headcount basis) in United States?
Your answer should be very brief. 5.96. In the year 2000, what is the difference between the Pupil-teacher ratio(headcount basis) of Spain and Pupil-teacher ratio(headcount basis) of Sweden?
Make the answer very short. -2.97. In the year 2000, what is the difference between the Pupil-teacher ratio(headcount basis) in Spain and Pupil-teacher ratio(headcount basis) in United States?
Offer a terse response. -3.22. In the year 2000, what is the difference between the Pupil-teacher ratio(headcount basis) in Sweden and Pupil-teacher ratio(headcount basis) in United States?
Your answer should be compact. -0.26. In the year 2001, what is the difference between the Pupil-teacher ratio(headcount basis) of Fragile and conflict affected situations and Pupil-teacher ratio(headcount basis) of Spain?
Ensure brevity in your answer.  9.54. In the year 2001, what is the difference between the Pupil-teacher ratio(headcount basis) in Fragile and conflict affected situations and Pupil-teacher ratio(headcount basis) in Sweden?
Your answer should be compact. 6.46. In the year 2001, what is the difference between the Pupil-teacher ratio(headcount basis) in Fragile and conflict affected situations and Pupil-teacher ratio(headcount basis) in United States?
Give a very brief answer. 5.25. In the year 2001, what is the difference between the Pupil-teacher ratio(headcount basis) of Spain and Pupil-teacher ratio(headcount basis) of Sweden?
Keep it short and to the point. -3.08. In the year 2001, what is the difference between the Pupil-teacher ratio(headcount basis) of Spain and Pupil-teacher ratio(headcount basis) of United States?
Offer a terse response. -4.29. In the year 2001, what is the difference between the Pupil-teacher ratio(headcount basis) in Sweden and Pupil-teacher ratio(headcount basis) in United States?
Provide a short and direct response. -1.21. In the year 2002, what is the difference between the Pupil-teacher ratio(headcount basis) of Fragile and conflict affected situations and Pupil-teacher ratio(headcount basis) of Spain?
Provide a succinct answer. 9.37. In the year 2002, what is the difference between the Pupil-teacher ratio(headcount basis) of Fragile and conflict affected situations and Pupil-teacher ratio(headcount basis) of Sweden?
Make the answer very short. 7.11. In the year 2002, what is the difference between the Pupil-teacher ratio(headcount basis) in Fragile and conflict affected situations and Pupil-teacher ratio(headcount basis) in United States?
Offer a terse response. 5.54. In the year 2002, what is the difference between the Pupil-teacher ratio(headcount basis) of Spain and Pupil-teacher ratio(headcount basis) of Sweden?
Ensure brevity in your answer.  -2.26. In the year 2002, what is the difference between the Pupil-teacher ratio(headcount basis) in Spain and Pupil-teacher ratio(headcount basis) in United States?
Keep it short and to the point. -3.84. In the year 2002, what is the difference between the Pupil-teacher ratio(headcount basis) in Sweden and Pupil-teacher ratio(headcount basis) in United States?
Offer a terse response. -1.57. In the year 2003, what is the difference between the Pupil-teacher ratio(headcount basis) of Fragile and conflict affected situations and Pupil-teacher ratio(headcount basis) of Spain?
Offer a very short reply. 9.14. In the year 2003, what is the difference between the Pupil-teacher ratio(headcount basis) of Fragile and conflict affected situations and Pupil-teacher ratio(headcount basis) of Sweden?
Ensure brevity in your answer.  7.52. In the year 2003, what is the difference between the Pupil-teacher ratio(headcount basis) in Fragile and conflict affected situations and Pupil-teacher ratio(headcount basis) in United States?
Your response must be concise. 5.33. In the year 2003, what is the difference between the Pupil-teacher ratio(headcount basis) of Spain and Pupil-teacher ratio(headcount basis) of Sweden?
Ensure brevity in your answer.  -1.62. In the year 2003, what is the difference between the Pupil-teacher ratio(headcount basis) in Spain and Pupil-teacher ratio(headcount basis) in United States?
Give a very brief answer. -3.81. In the year 2003, what is the difference between the Pupil-teacher ratio(headcount basis) in Sweden and Pupil-teacher ratio(headcount basis) in United States?
Make the answer very short. -2.19. In the year 2004, what is the difference between the Pupil-teacher ratio(headcount basis) in Fragile and conflict affected situations and Pupil-teacher ratio(headcount basis) in Spain?
Your answer should be very brief. 9.7. In the year 2004, what is the difference between the Pupil-teacher ratio(headcount basis) in Fragile and conflict affected situations and Pupil-teacher ratio(headcount basis) in Sweden?
Provide a succinct answer. 11.25. In the year 2004, what is the difference between the Pupil-teacher ratio(headcount basis) of Fragile and conflict affected situations and Pupil-teacher ratio(headcount basis) of United States?
Keep it short and to the point. 5.73. In the year 2004, what is the difference between the Pupil-teacher ratio(headcount basis) of Spain and Pupil-teacher ratio(headcount basis) of Sweden?
Provide a succinct answer. 1.55. In the year 2004, what is the difference between the Pupil-teacher ratio(headcount basis) in Spain and Pupil-teacher ratio(headcount basis) in United States?
Provide a succinct answer. -3.97. In the year 2004, what is the difference between the Pupil-teacher ratio(headcount basis) of Sweden and Pupil-teacher ratio(headcount basis) of United States?
Provide a short and direct response. -5.52. In the year 2005, what is the difference between the Pupil-teacher ratio(headcount basis) of Fragile and conflict affected situations and Pupil-teacher ratio(headcount basis) of Spain?
Keep it short and to the point. 9.43. In the year 2005, what is the difference between the Pupil-teacher ratio(headcount basis) of Fragile and conflict affected situations and Pupil-teacher ratio(headcount basis) of Sweden?
Offer a terse response. 10.86. In the year 2005, what is the difference between the Pupil-teacher ratio(headcount basis) of Fragile and conflict affected situations and Pupil-teacher ratio(headcount basis) of United States?
Your answer should be very brief. 5.58. In the year 2005, what is the difference between the Pupil-teacher ratio(headcount basis) in Spain and Pupil-teacher ratio(headcount basis) in Sweden?
Your answer should be very brief. 1.44. In the year 2005, what is the difference between the Pupil-teacher ratio(headcount basis) of Spain and Pupil-teacher ratio(headcount basis) of United States?
Make the answer very short. -3.85. In the year 2005, what is the difference between the Pupil-teacher ratio(headcount basis) of Sweden and Pupil-teacher ratio(headcount basis) of United States?
Ensure brevity in your answer.  -5.28. What is the ratio of the Pupil-teacher ratio(headcount basis) in Fragile and conflict affected situations in 1995 to that in 1999?
Your response must be concise. 0.91. What is the ratio of the Pupil-teacher ratio(headcount basis) of Spain in 1995 to that in 1999?
Your answer should be very brief. 1.33. What is the ratio of the Pupil-teacher ratio(headcount basis) of Sweden in 1995 to that in 1999?
Keep it short and to the point. 0.65. What is the ratio of the Pupil-teacher ratio(headcount basis) of United States in 1995 to that in 1999?
Provide a succinct answer. 1.03. What is the ratio of the Pupil-teacher ratio(headcount basis) of Fragile and conflict affected situations in 1995 to that in 2000?
Offer a very short reply. 0.92. What is the ratio of the Pupil-teacher ratio(headcount basis) of Spain in 1995 to that in 2000?
Give a very brief answer. 1.39. What is the ratio of the Pupil-teacher ratio(headcount basis) of Sweden in 1995 to that in 2000?
Make the answer very short. 0.68. What is the ratio of the Pupil-teacher ratio(headcount basis) in United States in 1995 to that in 2000?
Provide a succinct answer. 1.06. What is the ratio of the Pupil-teacher ratio(headcount basis) of Fragile and conflict affected situations in 1995 to that in 2001?
Make the answer very short. 0.93. What is the ratio of the Pupil-teacher ratio(headcount basis) in Spain in 1995 to that in 2001?
Offer a terse response. 1.46. What is the ratio of the Pupil-teacher ratio(headcount basis) of Sweden in 1995 to that in 2001?
Make the answer very short. 0.7. What is the ratio of the Pupil-teacher ratio(headcount basis) of United States in 1995 to that in 2001?
Your response must be concise. 1.02. What is the ratio of the Pupil-teacher ratio(headcount basis) of Fragile and conflict affected situations in 1995 to that in 2002?
Provide a short and direct response. 0.93. What is the ratio of the Pupil-teacher ratio(headcount basis) of Spain in 1995 to that in 2002?
Offer a terse response. 1.44. What is the ratio of the Pupil-teacher ratio(headcount basis) of Sweden in 1995 to that in 2002?
Provide a short and direct response. 0.73. What is the ratio of the Pupil-teacher ratio(headcount basis) in United States in 1995 to that in 2002?
Keep it short and to the point. 1.04. What is the ratio of the Pupil-teacher ratio(headcount basis) of Fragile and conflict affected situations in 1995 to that in 2003?
Provide a succinct answer. 0.94. What is the ratio of the Pupil-teacher ratio(headcount basis) in Spain in 1995 to that in 2003?
Give a very brief answer. 1.43. What is the ratio of the Pupil-teacher ratio(headcount basis) of Sweden in 1995 to that in 2003?
Provide a succinct answer. 0.76. What is the ratio of the Pupil-teacher ratio(headcount basis) of United States in 1995 to that in 2003?
Your answer should be very brief. 1.03. What is the ratio of the Pupil-teacher ratio(headcount basis) in Fragile and conflict affected situations in 1995 to that in 2004?
Offer a very short reply. 0.92. What is the ratio of the Pupil-teacher ratio(headcount basis) in Spain in 1995 to that in 2004?
Keep it short and to the point. 1.44. What is the ratio of the Pupil-teacher ratio(headcount basis) in Sweden in 1995 to that in 2004?
Make the answer very short. 1.03. What is the ratio of the Pupil-teacher ratio(headcount basis) in United States in 1995 to that in 2004?
Make the answer very short. 1.03. What is the ratio of the Pupil-teacher ratio(headcount basis) of Fragile and conflict affected situations in 1995 to that in 2005?
Give a very brief answer. 0.93. What is the ratio of the Pupil-teacher ratio(headcount basis) in Spain in 1995 to that in 2005?
Offer a very short reply. 1.43. What is the ratio of the Pupil-teacher ratio(headcount basis) in Sweden in 1995 to that in 2005?
Offer a terse response. 1.01. What is the ratio of the Pupil-teacher ratio(headcount basis) of United States in 1995 to that in 2005?
Offer a very short reply. 1.03. What is the ratio of the Pupil-teacher ratio(headcount basis) in Fragile and conflict affected situations in 1999 to that in 2000?
Your answer should be very brief. 1.01. What is the ratio of the Pupil-teacher ratio(headcount basis) of Spain in 1999 to that in 2000?
Provide a short and direct response. 1.05. What is the ratio of the Pupil-teacher ratio(headcount basis) of Sweden in 1999 to that in 2000?
Keep it short and to the point. 1.04. What is the ratio of the Pupil-teacher ratio(headcount basis) in United States in 1999 to that in 2000?
Your answer should be compact. 1.02. What is the ratio of the Pupil-teacher ratio(headcount basis) of Fragile and conflict affected situations in 1999 to that in 2001?
Your answer should be very brief. 1.02. What is the ratio of the Pupil-teacher ratio(headcount basis) in Spain in 1999 to that in 2001?
Offer a very short reply. 1.1. What is the ratio of the Pupil-teacher ratio(headcount basis) in Sweden in 1999 to that in 2001?
Offer a terse response. 1.07. What is the ratio of the Pupil-teacher ratio(headcount basis) in United States in 1999 to that in 2001?
Your answer should be very brief. 0.98. What is the ratio of the Pupil-teacher ratio(headcount basis) of Fragile and conflict affected situations in 1999 to that in 2002?
Ensure brevity in your answer.  1.02. What is the ratio of the Pupil-teacher ratio(headcount basis) of Spain in 1999 to that in 2002?
Your answer should be very brief. 1.08. What is the ratio of the Pupil-teacher ratio(headcount basis) in Sweden in 1999 to that in 2002?
Make the answer very short. 1.13. What is the ratio of the Pupil-teacher ratio(headcount basis) of United States in 1999 to that in 2002?
Offer a very short reply. 1. What is the ratio of the Pupil-teacher ratio(headcount basis) in Fragile and conflict affected situations in 1999 to that in 2003?
Provide a succinct answer. 1.03. What is the ratio of the Pupil-teacher ratio(headcount basis) in Spain in 1999 to that in 2003?
Offer a terse response. 1.07. What is the ratio of the Pupil-teacher ratio(headcount basis) in Sweden in 1999 to that in 2003?
Make the answer very short. 1.18. What is the ratio of the Pupil-teacher ratio(headcount basis) in United States in 1999 to that in 2003?
Give a very brief answer. 1. What is the ratio of the Pupil-teacher ratio(headcount basis) of Spain in 1999 to that in 2004?
Provide a short and direct response. 1.08. What is the ratio of the Pupil-teacher ratio(headcount basis) in Sweden in 1999 to that in 2004?
Make the answer very short. 1.58. What is the ratio of the Pupil-teacher ratio(headcount basis) in United States in 1999 to that in 2004?
Your answer should be very brief. 1. What is the ratio of the Pupil-teacher ratio(headcount basis) in Fragile and conflict affected situations in 1999 to that in 2005?
Your answer should be compact. 1.01. What is the ratio of the Pupil-teacher ratio(headcount basis) in Spain in 1999 to that in 2005?
Provide a succinct answer. 1.07. What is the ratio of the Pupil-teacher ratio(headcount basis) of Sweden in 1999 to that in 2005?
Provide a succinct answer. 1.55. What is the ratio of the Pupil-teacher ratio(headcount basis) of Fragile and conflict affected situations in 2000 to that in 2001?
Keep it short and to the point. 1.01. What is the ratio of the Pupil-teacher ratio(headcount basis) of Spain in 2000 to that in 2001?
Offer a very short reply. 1.05. What is the ratio of the Pupil-teacher ratio(headcount basis) in Sweden in 2000 to that in 2001?
Keep it short and to the point. 1.03. What is the ratio of the Pupil-teacher ratio(headcount basis) in United States in 2000 to that in 2001?
Offer a very short reply. 0.96. What is the ratio of the Pupil-teacher ratio(headcount basis) in Fragile and conflict affected situations in 2000 to that in 2002?
Give a very brief answer. 1.01. What is the ratio of the Pupil-teacher ratio(headcount basis) of Spain in 2000 to that in 2002?
Provide a succinct answer. 1.03. What is the ratio of the Pupil-teacher ratio(headcount basis) in Sweden in 2000 to that in 2002?
Give a very brief answer. 1.08. What is the ratio of the Pupil-teacher ratio(headcount basis) in United States in 2000 to that in 2002?
Offer a very short reply. 0.98. What is the ratio of the Pupil-teacher ratio(headcount basis) in Fragile and conflict affected situations in 2000 to that in 2003?
Your answer should be very brief. 1.02. What is the ratio of the Pupil-teacher ratio(headcount basis) in Spain in 2000 to that in 2003?
Offer a very short reply. 1.02. What is the ratio of the Pupil-teacher ratio(headcount basis) in Sweden in 2000 to that in 2003?
Make the answer very short. 1.13. What is the ratio of the Pupil-teacher ratio(headcount basis) in United States in 2000 to that in 2003?
Offer a terse response. 0.98. What is the ratio of the Pupil-teacher ratio(headcount basis) in Spain in 2000 to that in 2004?
Your answer should be very brief. 1.03. What is the ratio of the Pupil-teacher ratio(headcount basis) of Sweden in 2000 to that in 2004?
Ensure brevity in your answer.  1.52. What is the ratio of the Pupil-teacher ratio(headcount basis) in United States in 2000 to that in 2004?
Ensure brevity in your answer.  0.98. What is the ratio of the Pupil-teacher ratio(headcount basis) of Fragile and conflict affected situations in 2000 to that in 2005?
Offer a terse response. 1. What is the ratio of the Pupil-teacher ratio(headcount basis) in Spain in 2000 to that in 2005?
Offer a terse response. 1.03. What is the ratio of the Pupil-teacher ratio(headcount basis) in Sweden in 2000 to that in 2005?
Provide a short and direct response. 1.49. What is the ratio of the Pupil-teacher ratio(headcount basis) in United States in 2000 to that in 2005?
Keep it short and to the point. 0.98. What is the ratio of the Pupil-teacher ratio(headcount basis) in Spain in 2001 to that in 2002?
Keep it short and to the point. 0.98. What is the ratio of the Pupil-teacher ratio(headcount basis) of Sweden in 2001 to that in 2002?
Your response must be concise. 1.05. What is the ratio of the Pupil-teacher ratio(headcount basis) of United States in 2001 to that in 2002?
Offer a terse response. 1.02. What is the ratio of the Pupil-teacher ratio(headcount basis) in Fragile and conflict affected situations in 2001 to that in 2003?
Offer a very short reply. 1.01. What is the ratio of the Pupil-teacher ratio(headcount basis) of Spain in 2001 to that in 2003?
Ensure brevity in your answer.  0.98. What is the ratio of the Pupil-teacher ratio(headcount basis) in Sweden in 2001 to that in 2003?
Make the answer very short. 1.1. What is the ratio of the Pupil-teacher ratio(headcount basis) in United States in 2001 to that in 2003?
Your answer should be very brief. 1.02. What is the ratio of the Pupil-teacher ratio(headcount basis) of Fragile and conflict affected situations in 2001 to that in 2004?
Provide a short and direct response. 0.99. What is the ratio of the Pupil-teacher ratio(headcount basis) in Sweden in 2001 to that in 2004?
Your answer should be very brief. 1.48. What is the ratio of the Pupil-teacher ratio(headcount basis) in United States in 2001 to that in 2004?
Keep it short and to the point. 1.01. What is the ratio of the Pupil-teacher ratio(headcount basis) of Spain in 2001 to that in 2005?
Offer a terse response. 0.98. What is the ratio of the Pupil-teacher ratio(headcount basis) of Sweden in 2001 to that in 2005?
Offer a very short reply. 1.44. What is the ratio of the Pupil-teacher ratio(headcount basis) in United States in 2001 to that in 2005?
Make the answer very short. 1.01. What is the ratio of the Pupil-teacher ratio(headcount basis) of Fragile and conflict affected situations in 2002 to that in 2003?
Provide a succinct answer. 1.01. What is the ratio of the Pupil-teacher ratio(headcount basis) of Sweden in 2002 to that in 2003?
Provide a short and direct response. 1.05. What is the ratio of the Pupil-teacher ratio(headcount basis) of Fragile and conflict affected situations in 2002 to that in 2004?
Provide a short and direct response. 0.99. What is the ratio of the Pupil-teacher ratio(headcount basis) in Spain in 2002 to that in 2004?
Make the answer very short. 1. What is the ratio of the Pupil-teacher ratio(headcount basis) of Sweden in 2002 to that in 2004?
Your response must be concise. 1.41. What is the ratio of the Pupil-teacher ratio(headcount basis) in United States in 2002 to that in 2004?
Your answer should be compact. 0.99. What is the ratio of the Pupil-teacher ratio(headcount basis) of Sweden in 2002 to that in 2005?
Your answer should be very brief. 1.38. What is the ratio of the Pupil-teacher ratio(headcount basis) of United States in 2002 to that in 2005?
Give a very brief answer. 1. What is the ratio of the Pupil-teacher ratio(headcount basis) in Fragile and conflict affected situations in 2003 to that in 2004?
Your answer should be very brief. 0.98. What is the ratio of the Pupil-teacher ratio(headcount basis) in Spain in 2003 to that in 2004?
Make the answer very short. 1.01. What is the ratio of the Pupil-teacher ratio(headcount basis) in Sweden in 2003 to that in 2004?
Offer a terse response. 1.35. What is the ratio of the Pupil-teacher ratio(headcount basis) of Fragile and conflict affected situations in 2003 to that in 2005?
Your answer should be compact. 0.99. What is the ratio of the Pupil-teacher ratio(headcount basis) of Sweden in 2003 to that in 2005?
Ensure brevity in your answer.  1.32. What is the ratio of the Pupil-teacher ratio(headcount basis) in United States in 2003 to that in 2005?
Your answer should be very brief. 1. What is the ratio of the Pupil-teacher ratio(headcount basis) in Fragile and conflict affected situations in 2004 to that in 2005?
Ensure brevity in your answer.  1.01. What is the ratio of the Pupil-teacher ratio(headcount basis) of Sweden in 2004 to that in 2005?
Give a very brief answer. 0.98. What is the difference between the highest and the second highest Pupil-teacher ratio(headcount basis) of Fragile and conflict affected situations?
Ensure brevity in your answer.  0.07. What is the difference between the highest and the second highest Pupil-teacher ratio(headcount basis) in Spain?
Your response must be concise. 3.94. What is the difference between the highest and the second highest Pupil-teacher ratio(headcount basis) in Sweden?
Keep it short and to the point. 0.64. What is the difference between the highest and the second highest Pupil-teacher ratio(headcount basis) in United States?
Provide a short and direct response. 0.26. What is the difference between the highest and the lowest Pupil-teacher ratio(headcount basis) in Fragile and conflict affected situations?
Give a very brief answer. 1.79. What is the difference between the highest and the lowest Pupil-teacher ratio(headcount basis) of Spain?
Keep it short and to the point. 4.99. What is the difference between the highest and the lowest Pupil-teacher ratio(headcount basis) in Sweden?
Make the answer very short. 5.53. What is the difference between the highest and the lowest Pupil-teacher ratio(headcount basis) of United States?
Keep it short and to the point. 0.82. 